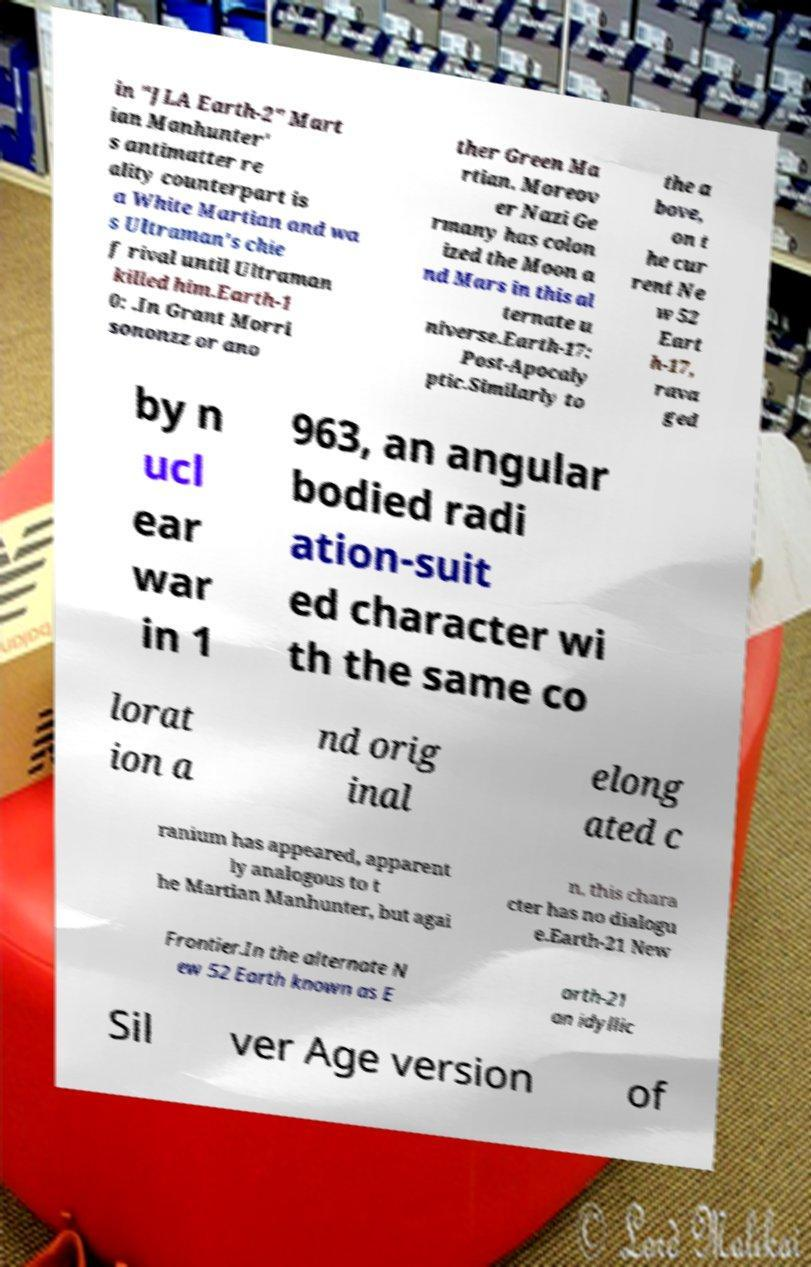Can you accurately transcribe the text from the provided image for me? in "JLA Earth-2" Mart ian Manhunter' s antimatter re ality counterpart is a White Martian and wa s Ultraman's chie f rival until Ultraman killed him.Earth-1 0: .In Grant Morri sononzz or ano ther Green Ma rtian. Moreov er Nazi Ge rmany has colon ized the Moon a nd Mars in this al ternate u niverse.Earth-17: Post-Apocaly ptic.Similarly to the a bove, on t he cur rent Ne w 52 Eart h-17, rava ged by n ucl ear war in 1 963, an angular bodied radi ation-suit ed character wi th the same co lorat ion a nd orig inal elong ated c ranium has appeared, apparent ly analogous to t he Martian Manhunter, but agai n, this chara cter has no dialogu e.Earth-21 New Frontier.In the alternate N ew 52 Earth known as E arth-21 an idyllic Sil ver Age version of 